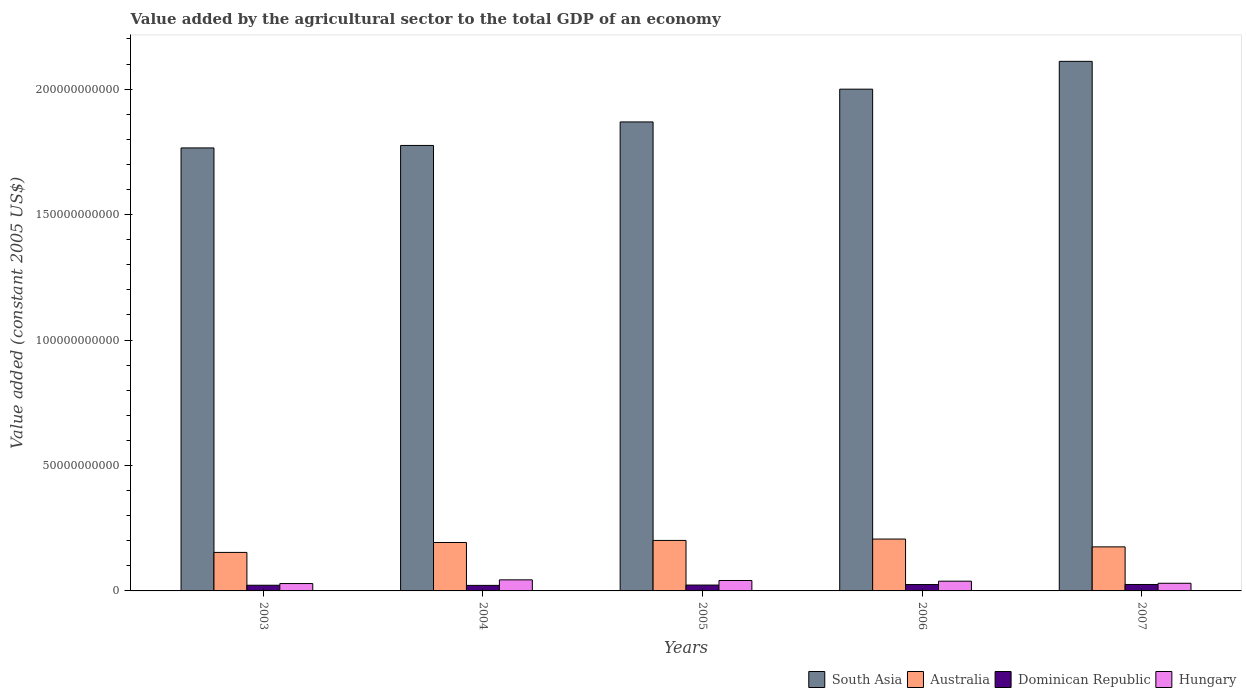How many different coloured bars are there?
Offer a terse response. 4. How many bars are there on the 1st tick from the left?
Keep it short and to the point. 4. What is the label of the 4th group of bars from the left?
Your answer should be very brief. 2006. What is the value added by the agricultural sector in Hungary in 2003?
Your answer should be compact. 2.94e+09. Across all years, what is the maximum value added by the agricultural sector in South Asia?
Provide a succinct answer. 2.11e+11. Across all years, what is the minimum value added by the agricultural sector in Australia?
Provide a short and direct response. 1.53e+1. In which year was the value added by the agricultural sector in Hungary maximum?
Offer a terse response. 2004. In which year was the value added by the agricultural sector in Dominican Republic minimum?
Make the answer very short. 2004. What is the total value added by the agricultural sector in South Asia in the graph?
Your answer should be very brief. 9.52e+11. What is the difference between the value added by the agricultural sector in Dominican Republic in 2003 and that in 2006?
Provide a short and direct response. -2.74e+08. What is the difference between the value added by the agricultural sector in South Asia in 2005 and the value added by the agricultural sector in Hungary in 2003?
Make the answer very short. 1.84e+11. What is the average value added by the agricultural sector in Hungary per year?
Provide a short and direct response. 3.69e+09. In the year 2003, what is the difference between the value added by the agricultural sector in Dominican Republic and value added by the agricultural sector in South Asia?
Provide a short and direct response. -1.74e+11. In how many years, is the value added by the agricultural sector in Australia greater than 130000000000 US$?
Give a very brief answer. 0. What is the ratio of the value added by the agricultural sector in South Asia in 2003 to that in 2007?
Ensure brevity in your answer.  0.84. Is the value added by the agricultural sector in Hungary in 2005 less than that in 2007?
Your answer should be compact. No. What is the difference between the highest and the second highest value added by the agricultural sector in Dominican Republic?
Your answer should be compact. 3.13e+07. What is the difference between the highest and the lowest value added by the agricultural sector in Dominican Republic?
Your response must be concise. 3.61e+08. In how many years, is the value added by the agricultural sector in Hungary greater than the average value added by the agricultural sector in Hungary taken over all years?
Ensure brevity in your answer.  3. Is it the case that in every year, the sum of the value added by the agricultural sector in South Asia and value added by the agricultural sector in Australia is greater than the sum of value added by the agricultural sector in Dominican Republic and value added by the agricultural sector in Hungary?
Your answer should be very brief. No. What does the 2nd bar from the right in 2003 represents?
Keep it short and to the point. Dominican Republic. What is the difference between two consecutive major ticks on the Y-axis?
Your answer should be compact. 5.00e+1. Are the values on the major ticks of Y-axis written in scientific E-notation?
Keep it short and to the point. No. Does the graph contain any zero values?
Provide a succinct answer. No. Does the graph contain grids?
Ensure brevity in your answer.  No. Where does the legend appear in the graph?
Keep it short and to the point. Bottom right. How many legend labels are there?
Ensure brevity in your answer.  4. What is the title of the graph?
Offer a very short reply. Value added by the agricultural sector to the total GDP of an economy. Does "Malawi" appear as one of the legend labels in the graph?
Give a very brief answer. No. What is the label or title of the X-axis?
Offer a very short reply. Years. What is the label or title of the Y-axis?
Offer a very short reply. Value added (constant 2005 US$). What is the Value added (constant 2005 US$) of South Asia in 2003?
Ensure brevity in your answer.  1.77e+11. What is the Value added (constant 2005 US$) of Australia in 2003?
Your response must be concise. 1.53e+1. What is the Value added (constant 2005 US$) of Dominican Republic in 2003?
Ensure brevity in your answer.  2.26e+09. What is the Value added (constant 2005 US$) in Hungary in 2003?
Give a very brief answer. 2.94e+09. What is the Value added (constant 2005 US$) of South Asia in 2004?
Your answer should be compact. 1.78e+11. What is the Value added (constant 2005 US$) in Australia in 2004?
Offer a terse response. 1.93e+1. What is the Value added (constant 2005 US$) of Dominican Republic in 2004?
Your response must be concise. 2.21e+09. What is the Value added (constant 2005 US$) of Hungary in 2004?
Offer a very short reply. 4.41e+09. What is the Value added (constant 2005 US$) in South Asia in 2005?
Offer a terse response. 1.87e+11. What is the Value added (constant 2005 US$) of Australia in 2005?
Offer a terse response. 2.01e+1. What is the Value added (constant 2005 US$) of Dominican Republic in 2005?
Make the answer very short. 2.34e+09. What is the Value added (constant 2005 US$) of Hungary in 2005?
Provide a short and direct response. 4.16e+09. What is the Value added (constant 2005 US$) in South Asia in 2006?
Your answer should be very brief. 2.00e+11. What is the Value added (constant 2005 US$) in Australia in 2006?
Keep it short and to the point. 2.07e+1. What is the Value added (constant 2005 US$) in Dominican Republic in 2006?
Give a very brief answer. 2.54e+09. What is the Value added (constant 2005 US$) in Hungary in 2006?
Offer a terse response. 3.88e+09. What is the Value added (constant 2005 US$) in South Asia in 2007?
Ensure brevity in your answer.  2.11e+11. What is the Value added (constant 2005 US$) of Australia in 2007?
Your response must be concise. 1.76e+1. What is the Value added (constant 2005 US$) of Dominican Republic in 2007?
Provide a short and direct response. 2.57e+09. What is the Value added (constant 2005 US$) of Hungary in 2007?
Offer a terse response. 3.05e+09. Across all years, what is the maximum Value added (constant 2005 US$) in South Asia?
Offer a very short reply. 2.11e+11. Across all years, what is the maximum Value added (constant 2005 US$) in Australia?
Keep it short and to the point. 2.07e+1. Across all years, what is the maximum Value added (constant 2005 US$) in Dominican Republic?
Your answer should be compact. 2.57e+09. Across all years, what is the maximum Value added (constant 2005 US$) in Hungary?
Offer a terse response. 4.41e+09. Across all years, what is the minimum Value added (constant 2005 US$) in South Asia?
Provide a short and direct response. 1.77e+11. Across all years, what is the minimum Value added (constant 2005 US$) of Australia?
Your response must be concise. 1.53e+1. Across all years, what is the minimum Value added (constant 2005 US$) of Dominican Republic?
Your answer should be compact. 2.21e+09. Across all years, what is the minimum Value added (constant 2005 US$) of Hungary?
Your answer should be very brief. 2.94e+09. What is the total Value added (constant 2005 US$) of South Asia in the graph?
Your answer should be compact. 9.52e+11. What is the total Value added (constant 2005 US$) in Australia in the graph?
Your answer should be very brief. 9.30e+1. What is the total Value added (constant 2005 US$) in Dominican Republic in the graph?
Ensure brevity in your answer.  1.19e+1. What is the total Value added (constant 2005 US$) of Hungary in the graph?
Your answer should be compact. 1.84e+1. What is the difference between the Value added (constant 2005 US$) of South Asia in 2003 and that in 2004?
Offer a terse response. -9.88e+08. What is the difference between the Value added (constant 2005 US$) of Australia in 2003 and that in 2004?
Offer a terse response. -3.96e+09. What is the difference between the Value added (constant 2005 US$) in Dominican Republic in 2003 and that in 2004?
Give a very brief answer. 5.61e+07. What is the difference between the Value added (constant 2005 US$) of Hungary in 2003 and that in 2004?
Provide a short and direct response. -1.47e+09. What is the difference between the Value added (constant 2005 US$) of South Asia in 2003 and that in 2005?
Make the answer very short. -1.04e+1. What is the difference between the Value added (constant 2005 US$) of Australia in 2003 and that in 2005?
Offer a very short reply. -4.78e+09. What is the difference between the Value added (constant 2005 US$) in Dominican Republic in 2003 and that in 2005?
Your answer should be very brief. -7.36e+07. What is the difference between the Value added (constant 2005 US$) in Hungary in 2003 and that in 2005?
Provide a short and direct response. -1.22e+09. What is the difference between the Value added (constant 2005 US$) in South Asia in 2003 and that in 2006?
Your answer should be compact. -2.34e+1. What is the difference between the Value added (constant 2005 US$) in Australia in 2003 and that in 2006?
Your response must be concise. -5.32e+09. What is the difference between the Value added (constant 2005 US$) of Dominican Republic in 2003 and that in 2006?
Your response must be concise. -2.74e+08. What is the difference between the Value added (constant 2005 US$) of Hungary in 2003 and that in 2006?
Ensure brevity in your answer.  -9.49e+08. What is the difference between the Value added (constant 2005 US$) of South Asia in 2003 and that in 2007?
Your answer should be compact. -3.45e+1. What is the difference between the Value added (constant 2005 US$) in Australia in 2003 and that in 2007?
Provide a succinct answer. -2.21e+09. What is the difference between the Value added (constant 2005 US$) of Dominican Republic in 2003 and that in 2007?
Make the answer very short. -3.05e+08. What is the difference between the Value added (constant 2005 US$) of Hungary in 2003 and that in 2007?
Your answer should be very brief. -1.14e+08. What is the difference between the Value added (constant 2005 US$) of South Asia in 2004 and that in 2005?
Your answer should be very brief. -9.37e+09. What is the difference between the Value added (constant 2005 US$) of Australia in 2004 and that in 2005?
Your answer should be compact. -8.19e+08. What is the difference between the Value added (constant 2005 US$) of Dominican Republic in 2004 and that in 2005?
Provide a short and direct response. -1.30e+08. What is the difference between the Value added (constant 2005 US$) of Hungary in 2004 and that in 2005?
Offer a terse response. 2.54e+08. What is the difference between the Value added (constant 2005 US$) in South Asia in 2004 and that in 2006?
Keep it short and to the point. -2.24e+1. What is the difference between the Value added (constant 2005 US$) of Australia in 2004 and that in 2006?
Provide a short and direct response. -1.36e+09. What is the difference between the Value added (constant 2005 US$) in Dominican Republic in 2004 and that in 2006?
Keep it short and to the point. -3.30e+08. What is the difference between the Value added (constant 2005 US$) in Hungary in 2004 and that in 2006?
Make the answer very short. 5.26e+08. What is the difference between the Value added (constant 2005 US$) in South Asia in 2004 and that in 2007?
Your response must be concise. -3.35e+1. What is the difference between the Value added (constant 2005 US$) in Australia in 2004 and that in 2007?
Offer a very short reply. 1.75e+09. What is the difference between the Value added (constant 2005 US$) in Dominican Republic in 2004 and that in 2007?
Offer a terse response. -3.61e+08. What is the difference between the Value added (constant 2005 US$) of Hungary in 2004 and that in 2007?
Keep it short and to the point. 1.36e+09. What is the difference between the Value added (constant 2005 US$) of South Asia in 2005 and that in 2006?
Provide a short and direct response. -1.31e+1. What is the difference between the Value added (constant 2005 US$) in Australia in 2005 and that in 2006?
Give a very brief answer. -5.45e+08. What is the difference between the Value added (constant 2005 US$) in Dominican Republic in 2005 and that in 2006?
Provide a succinct answer. -2.00e+08. What is the difference between the Value added (constant 2005 US$) in Hungary in 2005 and that in 2006?
Ensure brevity in your answer.  2.72e+08. What is the difference between the Value added (constant 2005 US$) in South Asia in 2005 and that in 2007?
Make the answer very short. -2.41e+1. What is the difference between the Value added (constant 2005 US$) of Australia in 2005 and that in 2007?
Your answer should be compact. 2.57e+09. What is the difference between the Value added (constant 2005 US$) of Dominican Republic in 2005 and that in 2007?
Make the answer very short. -2.32e+08. What is the difference between the Value added (constant 2005 US$) of Hungary in 2005 and that in 2007?
Provide a short and direct response. 1.11e+09. What is the difference between the Value added (constant 2005 US$) of South Asia in 2006 and that in 2007?
Offer a terse response. -1.11e+1. What is the difference between the Value added (constant 2005 US$) in Australia in 2006 and that in 2007?
Your response must be concise. 3.11e+09. What is the difference between the Value added (constant 2005 US$) in Dominican Republic in 2006 and that in 2007?
Your response must be concise. -3.13e+07. What is the difference between the Value added (constant 2005 US$) of Hungary in 2006 and that in 2007?
Give a very brief answer. 8.35e+08. What is the difference between the Value added (constant 2005 US$) of South Asia in 2003 and the Value added (constant 2005 US$) of Australia in 2004?
Provide a short and direct response. 1.57e+11. What is the difference between the Value added (constant 2005 US$) of South Asia in 2003 and the Value added (constant 2005 US$) of Dominican Republic in 2004?
Provide a short and direct response. 1.74e+11. What is the difference between the Value added (constant 2005 US$) in South Asia in 2003 and the Value added (constant 2005 US$) in Hungary in 2004?
Ensure brevity in your answer.  1.72e+11. What is the difference between the Value added (constant 2005 US$) of Australia in 2003 and the Value added (constant 2005 US$) of Dominican Republic in 2004?
Make the answer very short. 1.31e+1. What is the difference between the Value added (constant 2005 US$) in Australia in 2003 and the Value added (constant 2005 US$) in Hungary in 2004?
Make the answer very short. 1.09e+1. What is the difference between the Value added (constant 2005 US$) in Dominican Republic in 2003 and the Value added (constant 2005 US$) in Hungary in 2004?
Keep it short and to the point. -2.15e+09. What is the difference between the Value added (constant 2005 US$) of South Asia in 2003 and the Value added (constant 2005 US$) of Australia in 2005?
Give a very brief answer. 1.56e+11. What is the difference between the Value added (constant 2005 US$) in South Asia in 2003 and the Value added (constant 2005 US$) in Dominican Republic in 2005?
Your answer should be very brief. 1.74e+11. What is the difference between the Value added (constant 2005 US$) of South Asia in 2003 and the Value added (constant 2005 US$) of Hungary in 2005?
Provide a short and direct response. 1.72e+11. What is the difference between the Value added (constant 2005 US$) in Australia in 2003 and the Value added (constant 2005 US$) in Dominican Republic in 2005?
Ensure brevity in your answer.  1.30e+1. What is the difference between the Value added (constant 2005 US$) in Australia in 2003 and the Value added (constant 2005 US$) in Hungary in 2005?
Offer a terse response. 1.12e+1. What is the difference between the Value added (constant 2005 US$) of Dominican Republic in 2003 and the Value added (constant 2005 US$) of Hungary in 2005?
Offer a terse response. -1.89e+09. What is the difference between the Value added (constant 2005 US$) in South Asia in 2003 and the Value added (constant 2005 US$) in Australia in 2006?
Ensure brevity in your answer.  1.56e+11. What is the difference between the Value added (constant 2005 US$) of South Asia in 2003 and the Value added (constant 2005 US$) of Dominican Republic in 2006?
Your answer should be compact. 1.74e+11. What is the difference between the Value added (constant 2005 US$) of South Asia in 2003 and the Value added (constant 2005 US$) of Hungary in 2006?
Make the answer very short. 1.73e+11. What is the difference between the Value added (constant 2005 US$) in Australia in 2003 and the Value added (constant 2005 US$) in Dominican Republic in 2006?
Offer a terse response. 1.28e+1. What is the difference between the Value added (constant 2005 US$) of Australia in 2003 and the Value added (constant 2005 US$) of Hungary in 2006?
Your answer should be very brief. 1.15e+1. What is the difference between the Value added (constant 2005 US$) in Dominican Republic in 2003 and the Value added (constant 2005 US$) in Hungary in 2006?
Offer a very short reply. -1.62e+09. What is the difference between the Value added (constant 2005 US$) of South Asia in 2003 and the Value added (constant 2005 US$) of Australia in 2007?
Your answer should be compact. 1.59e+11. What is the difference between the Value added (constant 2005 US$) in South Asia in 2003 and the Value added (constant 2005 US$) in Dominican Republic in 2007?
Your answer should be compact. 1.74e+11. What is the difference between the Value added (constant 2005 US$) of South Asia in 2003 and the Value added (constant 2005 US$) of Hungary in 2007?
Provide a short and direct response. 1.74e+11. What is the difference between the Value added (constant 2005 US$) in Australia in 2003 and the Value added (constant 2005 US$) in Dominican Republic in 2007?
Give a very brief answer. 1.28e+1. What is the difference between the Value added (constant 2005 US$) in Australia in 2003 and the Value added (constant 2005 US$) in Hungary in 2007?
Provide a short and direct response. 1.23e+1. What is the difference between the Value added (constant 2005 US$) of Dominican Republic in 2003 and the Value added (constant 2005 US$) of Hungary in 2007?
Your answer should be compact. -7.87e+08. What is the difference between the Value added (constant 2005 US$) in South Asia in 2004 and the Value added (constant 2005 US$) in Australia in 2005?
Offer a terse response. 1.57e+11. What is the difference between the Value added (constant 2005 US$) of South Asia in 2004 and the Value added (constant 2005 US$) of Dominican Republic in 2005?
Offer a terse response. 1.75e+11. What is the difference between the Value added (constant 2005 US$) of South Asia in 2004 and the Value added (constant 2005 US$) of Hungary in 2005?
Offer a very short reply. 1.73e+11. What is the difference between the Value added (constant 2005 US$) in Australia in 2004 and the Value added (constant 2005 US$) in Dominican Republic in 2005?
Make the answer very short. 1.70e+1. What is the difference between the Value added (constant 2005 US$) of Australia in 2004 and the Value added (constant 2005 US$) of Hungary in 2005?
Your answer should be compact. 1.51e+1. What is the difference between the Value added (constant 2005 US$) of Dominican Republic in 2004 and the Value added (constant 2005 US$) of Hungary in 2005?
Provide a short and direct response. -1.95e+09. What is the difference between the Value added (constant 2005 US$) in South Asia in 2004 and the Value added (constant 2005 US$) in Australia in 2006?
Offer a terse response. 1.57e+11. What is the difference between the Value added (constant 2005 US$) of South Asia in 2004 and the Value added (constant 2005 US$) of Dominican Republic in 2006?
Make the answer very short. 1.75e+11. What is the difference between the Value added (constant 2005 US$) in South Asia in 2004 and the Value added (constant 2005 US$) in Hungary in 2006?
Keep it short and to the point. 1.74e+11. What is the difference between the Value added (constant 2005 US$) in Australia in 2004 and the Value added (constant 2005 US$) in Dominican Republic in 2006?
Ensure brevity in your answer.  1.68e+1. What is the difference between the Value added (constant 2005 US$) in Australia in 2004 and the Value added (constant 2005 US$) in Hungary in 2006?
Your answer should be very brief. 1.54e+1. What is the difference between the Value added (constant 2005 US$) in Dominican Republic in 2004 and the Value added (constant 2005 US$) in Hungary in 2006?
Keep it short and to the point. -1.68e+09. What is the difference between the Value added (constant 2005 US$) of South Asia in 2004 and the Value added (constant 2005 US$) of Australia in 2007?
Make the answer very short. 1.60e+11. What is the difference between the Value added (constant 2005 US$) of South Asia in 2004 and the Value added (constant 2005 US$) of Dominican Republic in 2007?
Provide a short and direct response. 1.75e+11. What is the difference between the Value added (constant 2005 US$) of South Asia in 2004 and the Value added (constant 2005 US$) of Hungary in 2007?
Your answer should be compact. 1.74e+11. What is the difference between the Value added (constant 2005 US$) of Australia in 2004 and the Value added (constant 2005 US$) of Dominican Republic in 2007?
Provide a short and direct response. 1.67e+1. What is the difference between the Value added (constant 2005 US$) in Australia in 2004 and the Value added (constant 2005 US$) in Hungary in 2007?
Keep it short and to the point. 1.63e+1. What is the difference between the Value added (constant 2005 US$) of Dominican Republic in 2004 and the Value added (constant 2005 US$) of Hungary in 2007?
Provide a succinct answer. -8.43e+08. What is the difference between the Value added (constant 2005 US$) of South Asia in 2005 and the Value added (constant 2005 US$) of Australia in 2006?
Your response must be concise. 1.66e+11. What is the difference between the Value added (constant 2005 US$) of South Asia in 2005 and the Value added (constant 2005 US$) of Dominican Republic in 2006?
Your answer should be very brief. 1.84e+11. What is the difference between the Value added (constant 2005 US$) of South Asia in 2005 and the Value added (constant 2005 US$) of Hungary in 2006?
Your answer should be compact. 1.83e+11. What is the difference between the Value added (constant 2005 US$) in Australia in 2005 and the Value added (constant 2005 US$) in Dominican Republic in 2006?
Offer a terse response. 1.76e+1. What is the difference between the Value added (constant 2005 US$) of Australia in 2005 and the Value added (constant 2005 US$) of Hungary in 2006?
Offer a very short reply. 1.62e+1. What is the difference between the Value added (constant 2005 US$) in Dominican Republic in 2005 and the Value added (constant 2005 US$) in Hungary in 2006?
Your response must be concise. -1.55e+09. What is the difference between the Value added (constant 2005 US$) in South Asia in 2005 and the Value added (constant 2005 US$) in Australia in 2007?
Your response must be concise. 1.69e+11. What is the difference between the Value added (constant 2005 US$) in South Asia in 2005 and the Value added (constant 2005 US$) in Dominican Republic in 2007?
Give a very brief answer. 1.84e+11. What is the difference between the Value added (constant 2005 US$) of South Asia in 2005 and the Value added (constant 2005 US$) of Hungary in 2007?
Your response must be concise. 1.84e+11. What is the difference between the Value added (constant 2005 US$) in Australia in 2005 and the Value added (constant 2005 US$) in Dominican Republic in 2007?
Offer a very short reply. 1.76e+1. What is the difference between the Value added (constant 2005 US$) of Australia in 2005 and the Value added (constant 2005 US$) of Hungary in 2007?
Provide a short and direct response. 1.71e+1. What is the difference between the Value added (constant 2005 US$) in Dominican Republic in 2005 and the Value added (constant 2005 US$) in Hungary in 2007?
Your answer should be compact. -7.13e+08. What is the difference between the Value added (constant 2005 US$) of South Asia in 2006 and the Value added (constant 2005 US$) of Australia in 2007?
Your answer should be very brief. 1.82e+11. What is the difference between the Value added (constant 2005 US$) in South Asia in 2006 and the Value added (constant 2005 US$) in Dominican Republic in 2007?
Give a very brief answer. 1.97e+11. What is the difference between the Value added (constant 2005 US$) of South Asia in 2006 and the Value added (constant 2005 US$) of Hungary in 2007?
Offer a terse response. 1.97e+11. What is the difference between the Value added (constant 2005 US$) in Australia in 2006 and the Value added (constant 2005 US$) in Dominican Republic in 2007?
Provide a succinct answer. 1.81e+1. What is the difference between the Value added (constant 2005 US$) in Australia in 2006 and the Value added (constant 2005 US$) in Hungary in 2007?
Offer a very short reply. 1.76e+1. What is the difference between the Value added (constant 2005 US$) of Dominican Republic in 2006 and the Value added (constant 2005 US$) of Hungary in 2007?
Provide a short and direct response. -5.13e+08. What is the average Value added (constant 2005 US$) of South Asia per year?
Your answer should be very brief. 1.90e+11. What is the average Value added (constant 2005 US$) in Australia per year?
Your answer should be very brief. 1.86e+1. What is the average Value added (constant 2005 US$) of Dominican Republic per year?
Ensure brevity in your answer.  2.38e+09. What is the average Value added (constant 2005 US$) of Hungary per year?
Give a very brief answer. 3.69e+09. In the year 2003, what is the difference between the Value added (constant 2005 US$) of South Asia and Value added (constant 2005 US$) of Australia?
Your answer should be very brief. 1.61e+11. In the year 2003, what is the difference between the Value added (constant 2005 US$) of South Asia and Value added (constant 2005 US$) of Dominican Republic?
Ensure brevity in your answer.  1.74e+11. In the year 2003, what is the difference between the Value added (constant 2005 US$) of South Asia and Value added (constant 2005 US$) of Hungary?
Keep it short and to the point. 1.74e+11. In the year 2003, what is the difference between the Value added (constant 2005 US$) in Australia and Value added (constant 2005 US$) in Dominican Republic?
Your response must be concise. 1.31e+1. In the year 2003, what is the difference between the Value added (constant 2005 US$) in Australia and Value added (constant 2005 US$) in Hungary?
Offer a very short reply. 1.24e+1. In the year 2003, what is the difference between the Value added (constant 2005 US$) in Dominican Republic and Value added (constant 2005 US$) in Hungary?
Your answer should be very brief. -6.72e+08. In the year 2004, what is the difference between the Value added (constant 2005 US$) of South Asia and Value added (constant 2005 US$) of Australia?
Make the answer very short. 1.58e+11. In the year 2004, what is the difference between the Value added (constant 2005 US$) in South Asia and Value added (constant 2005 US$) in Dominican Republic?
Offer a terse response. 1.75e+11. In the year 2004, what is the difference between the Value added (constant 2005 US$) in South Asia and Value added (constant 2005 US$) in Hungary?
Make the answer very short. 1.73e+11. In the year 2004, what is the difference between the Value added (constant 2005 US$) in Australia and Value added (constant 2005 US$) in Dominican Republic?
Make the answer very short. 1.71e+1. In the year 2004, what is the difference between the Value added (constant 2005 US$) in Australia and Value added (constant 2005 US$) in Hungary?
Your answer should be compact. 1.49e+1. In the year 2004, what is the difference between the Value added (constant 2005 US$) of Dominican Republic and Value added (constant 2005 US$) of Hungary?
Provide a succinct answer. -2.20e+09. In the year 2005, what is the difference between the Value added (constant 2005 US$) of South Asia and Value added (constant 2005 US$) of Australia?
Make the answer very short. 1.67e+11. In the year 2005, what is the difference between the Value added (constant 2005 US$) in South Asia and Value added (constant 2005 US$) in Dominican Republic?
Your response must be concise. 1.85e+11. In the year 2005, what is the difference between the Value added (constant 2005 US$) of South Asia and Value added (constant 2005 US$) of Hungary?
Make the answer very short. 1.83e+11. In the year 2005, what is the difference between the Value added (constant 2005 US$) of Australia and Value added (constant 2005 US$) of Dominican Republic?
Your answer should be very brief. 1.78e+1. In the year 2005, what is the difference between the Value added (constant 2005 US$) of Australia and Value added (constant 2005 US$) of Hungary?
Your answer should be very brief. 1.60e+1. In the year 2005, what is the difference between the Value added (constant 2005 US$) in Dominican Republic and Value added (constant 2005 US$) in Hungary?
Provide a short and direct response. -1.82e+09. In the year 2006, what is the difference between the Value added (constant 2005 US$) of South Asia and Value added (constant 2005 US$) of Australia?
Offer a terse response. 1.79e+11. In the year 2006, what is the difference between the Value added (constant 2005 US$) in South Asia and Value added (constant 2005 US$) in Dominican Republic?
Give a very brief answer. 1.97e+11. In the year 2006, what is the difference between the Value added (constant 2005 US$) in South Asia and Value added (constant 2005 US$) in Hungary?
Your answer should be very brief. 1.96e+11. In the year 2006, what is the difference between the Value added (constant 2005 US$) in Australia and Value added (constant 2005 US$) in Dominican Republic?
Your response must be concise. 1.81e+1. In the year 2006, what is the difference between the Value added (constant 2005 US$) in Australia and Value added (constant 2005 US$) in Hungary?
Offer a very short reply. 1.68e+1. In the year 2006, what is the difference between the Value added (constant 2005 US$) of Dominican Republic and Value added (constant 2005 US$) of Hungary?
Provide a short and direct response. -1.35e+09. In the year 2007, what is the difference between the Value added (constant 2005 US$) in South Asia and Value added (constant 2005 US$) in Australia?
Offer a very short reply. 1.94e+11. In the year 2007, what is the difference between the Value added (constant 2005 US$) of South Asia and Value added (constant 2005 US$) of Dominican Republic?
Give a very brief answer. 2.08e+11. In the year 2007, what is the difference between the Value added (constant 2005 US$) of South Asia and Value added (constant 2005 US$) of Hungary?
Your response must be concise. 2.08e+11. In the year 2007, what is the difference between the Value added (constant 2005 US$) of Australia and Value added (constant 2005 US$) of Dominican Republic?
Ensure brevity in your answer.  1.50e+1. In the year 2007, what is the difference between the Value added (constant 2005 US$) in Australia and Value added (constant 2005 US$) in Hungary?
Provide a short and direct response. 1.45e+1. In the year 2007, what is the difference between the Value added (constant 2005 US$) in Dominican Republic and Value added (constant 2005 US$) in Hungary?
Your answer should be compact. -4.81e+08. What is the ratio of the Value added (constant 2005 US$) of South Asia in 2003 to that in 2004?
Make the answer very short. 0.99. What is the ratio of the Value added (constant 2005 US$) in Australia in 2003 to that in 2004?
Provide a short and direct response. 0.79. What is the ratio of the Value added (constant 2005 US$) of Dominican Republic in 2003 to that in 2004?
Provide a succinct answer. 1.03. What is the ratio of the Value added (constant 2005 US$) in Hungary in 2003 to that in 2004?
Your response must be concise. 0.67. What is the ratio of the Value added (constant 2005 US$) in South Asia in 2003 to that in 2005?
Ensure brevity in your answer.  0.94. What is the ratio of the Value added (constant 2005 US$) of Australia in 2003 to that in 2005?
Your answer should be compact. 0.76. What is the ratio of the Value added (constant 2005 US$) in Dominican Republic in 2003 to that in 2005?
Ensure brevity in your answer.  0.97. What is the ratio of the Value added (constant 2005 US$) of Hungary in 2003 to that in 2005?
Ensure brevity in your answer.  0.71. What is the ratio of the Value added (constant 2005 US$) of South Asia in 2003 to that in 2006?
Provide a succinct answer. 0.88. What is the ratio of the Value added (constant 2005 US$) in Australia in 2003 to that in 2006?
Provide a short and direct response. 0.74. What is the ratio of the Value added (constant 2005 US$) of Dominican Republic in 2003 to that in 2006?
Keep it short and to the point. 0.89. What is the ratio of the Value added (constant 2005 US$) of Hungary in 2003 to that in 2006?
Give a very brief answer. 0.76. What is the ratio of the Value added (constant 2005 US$) of South Asia in 2003 to that in 2007?
Your response must be concise. 0.84. What is the ratio of the Value added (constant 2005 US$) in Australia in 2003 to that in 2007?
Your response must be concise. 0.87. What is the ratio of the Value added (constant 2005 US$) of Dominican Republic in 2003 to that in 2007?
Give a very brief answer. 0.88. What is the ratio of the Value added (constant 2005 US$) in Hungary in 2003 to that in 2007?
Offer a terse response. 0.96. What is the ratio of the Value added (constant 2005 US$) in South Asia in 2004 to that in 2005?
Your answer should be very brief. 0.95. What is the ratio of the Value added (constant 2005 US$) of Australia in 2004 to that in 2005?
Provide a short and direct response. 0.96. What is the ratio of the Value added (constant 2005 US$) in Dominican Republic in 2004 to that in 2005?
Keep it short and to the point. 0.94. What is the ratio of the Value added (constant 2005 US$) in Hungary in 2004 to that in 2005?
Offer a very short reply. 1.06. What is the ratio of the Value added (constant 2005 US$) of South Asia in 2004 to that in 2006?
Offer a very short reply. 0.89. What is the ratio of the Value added (constant 2005 US$) of Australia in 2004 to that in 2006?
Provide a succinct answer. 0.93. What is the ratio of the Value added (constant 2005 US$) of Dominican Republic in 2004 to that in 2006?
Keep it short and to the point. 0.87. What is the ratio of the Value added (constant 2005 US$) in Hungary in 2004 to that in 2006?
Ensure brevity in your answer.  1.14. What is the ratio of the Value added (constant 2005 US$) in South Asia in 2004 to that in 2007?
Your response must be concise. 0.84. What is the ratio of the Value added (constant 2005 US$) of Australia in 2004 to that in 2007?
Give a very brief answer. 1.1. What is the ratio of the Value added (constant 2005 US$) of Dominican Republic in 2004 to that in 2007?
Give a very brief answer. 0.86. What is the ratio of the Value added (constant 2005 US$) in Hungary in 2004 to that in 2007?
Make the answer very short. 1.45. What is the ratio of the Value added (constant 2005 US$) of South Asia in 2005 to that in 2006?
Offer a terse response. 0.93. What is the ratio of the Value added (constant 2005 US$) of Australia in 2005 to that in 2006?
Offer a very short reply. 0.97. What is the ratio of the Value added (constant 2005 US$) in Dominican Republic in 2005 to that in 2006?
Keep it short and to the point. 0.92. What is the ratio of the Value added (constant 2005 US$) of Hungary in 2005 to that in 2006?
Your answer should be very brief. 1.07. What is the ratio of the Value added (constant 2005 US$) in South Asia in 2005 to that in 2007?
Your answer should be compact. 0.89. What is the ratio of the Value added (constant 2005 US$) in Australia in 2005 to that in 2007?
Offer a very short reply. 1.15. What is the ratio of the Value added (constant 2005 US$) in Dominican Republic in 2005 to that in 2007?
Provide a succinct answer. 0.91. What is the ratio of the Value added (constant 2005 US$) of Hungary in 2005 to that in 2007?
Give a very brief answer. 1.36. What is the ratio of the Value added (constant 2005 US$) of South Asia in 2006 to that in 2007?
Offer a very short reply. 0.95. What is the ratio of the Value added (constant 2005 US$) in Australia in 2006 to that in 2007?
Your answer should be very brief. 1.18. What is the ratio of the Value added (constant 2005 US$) in Dominican Republic in 2006 to that in 2007?
Your answer should be very brief. 0.99. What is the ratio of the Value added (constant 2005 US$) of Hungary in 2006 to that in 2007?
Offer a very short reply. 1.27. What is the difference between the highest and the second highest Value added (constant 2005 US$) of South Asia?
Your answer should be compact. 1.11e+1. What is the difference between the highest and the second highest Value added (constant 2005 US$) in Australia?
Provide a succinct answer. 5.45e+08. What is the difference between the highest and the second highest Value added (constant 2005 US$) of Dominican Republic?
Offer a terse response. 3.13e+07. What is the difference between the highest and the second highest Value added (constant 2005 US$) of Hungary?
Your response must be concise. 2.54e+08. What is the difference between the highest and the lowest Value added (constant 2005 US$) in South Asia?
Ensure brevity in your answer.  3.45e+1. What is the difference between the highest and the lowest Value added (constant 2005 US$) in Australia?
Offer a very short reply. 5.32e+09. What is the difference between the highest and the lowest Value added (constant 2005 US$) of Dominican Republic?
Your answer should be very brief. 3.61e+08. What is the difference between the highest and the lowest Value added (constant 2005 US$) in Hungary?
Make the answer very short. 1.47e+09. 